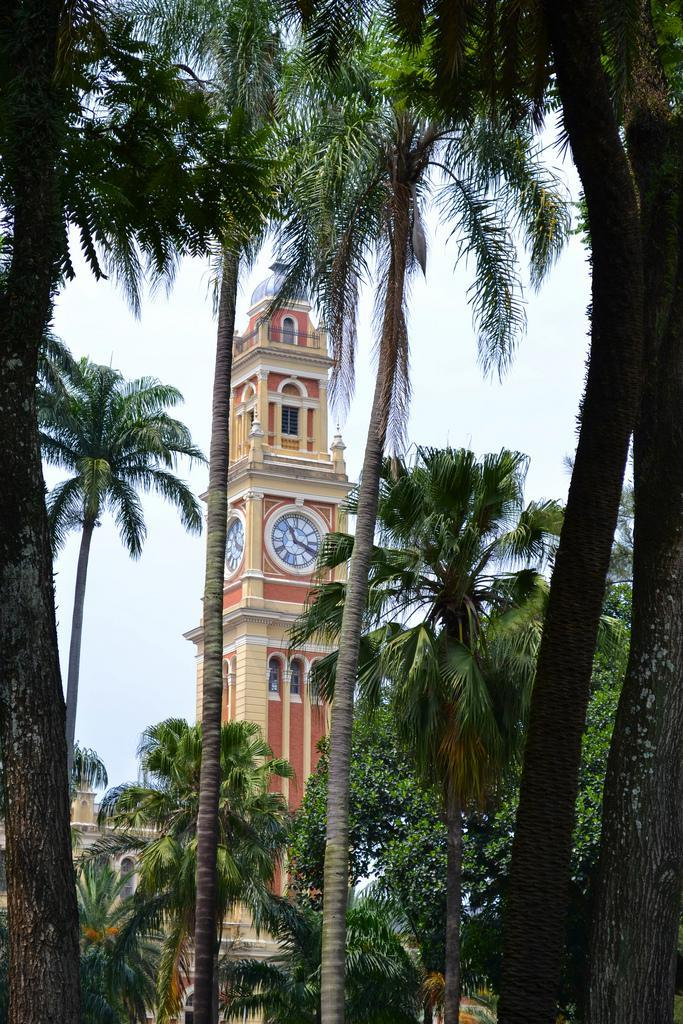What type of trees are in the foreground of the picture? There are palm trees in the foreground of the picture. What structure can be seen in the background of the picture? There is a clock tower in the background of the picture. What is the condition of the sky in the picture? The sky is cloudy in the picture. What sign can be seen on the palm trees in the image? There are no signs visible on the palm trees in the image. How many sons are present in the image? There is no reference to any sons in the image, as it features palm trees and a clock tower. 